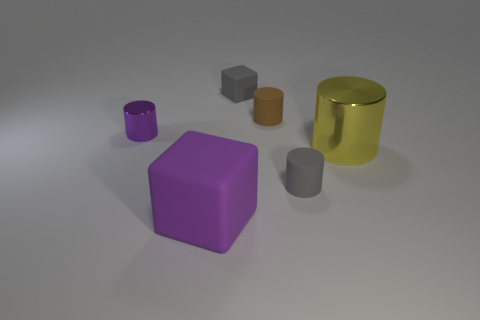Subtract all brown matte cylinders. How many cylinders are left? 3 Subtract all blocks. How many objects are left? 4 Subtract 1 cylinders. How many cylinders are left? 3 Add 1 tiny red shiny spheres. How many objects exist? 7 Subtract all tiny cyan matte cylinders. Subtract all tiny cylinders. How many objects are left? 3 Add 6 purple blocks. How many purple blocks are left? 7 Add 2 small cylinders. How many small cylinders exist? 5 Subtract all purple cylinders. How many cylinders are left? 3 Subtract 0 green balls. How many objects are left? 6 Subtract all yellow blocks. Subtract all green cylinders. How many blocks are left? 2 